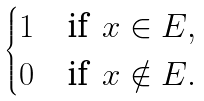Convert formula to latex. <formula><loc_0><loc_0><loc_500><loc_500>\begin{cases} 1 & \text {if } \, x \in E , \\ 0 & \text {if } \, x \notin E . \end{cases}</formula> 